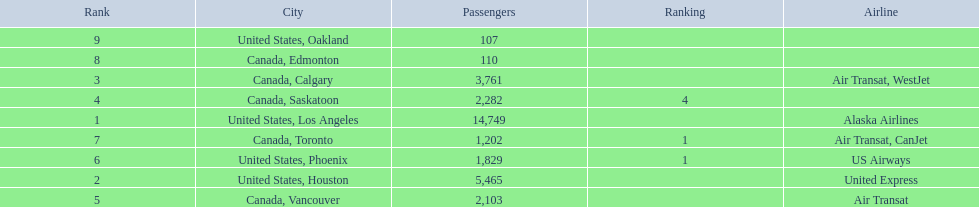Was los angeles or houston the busiest international route at manzanillo international airport in 2013? Los Angeles. 